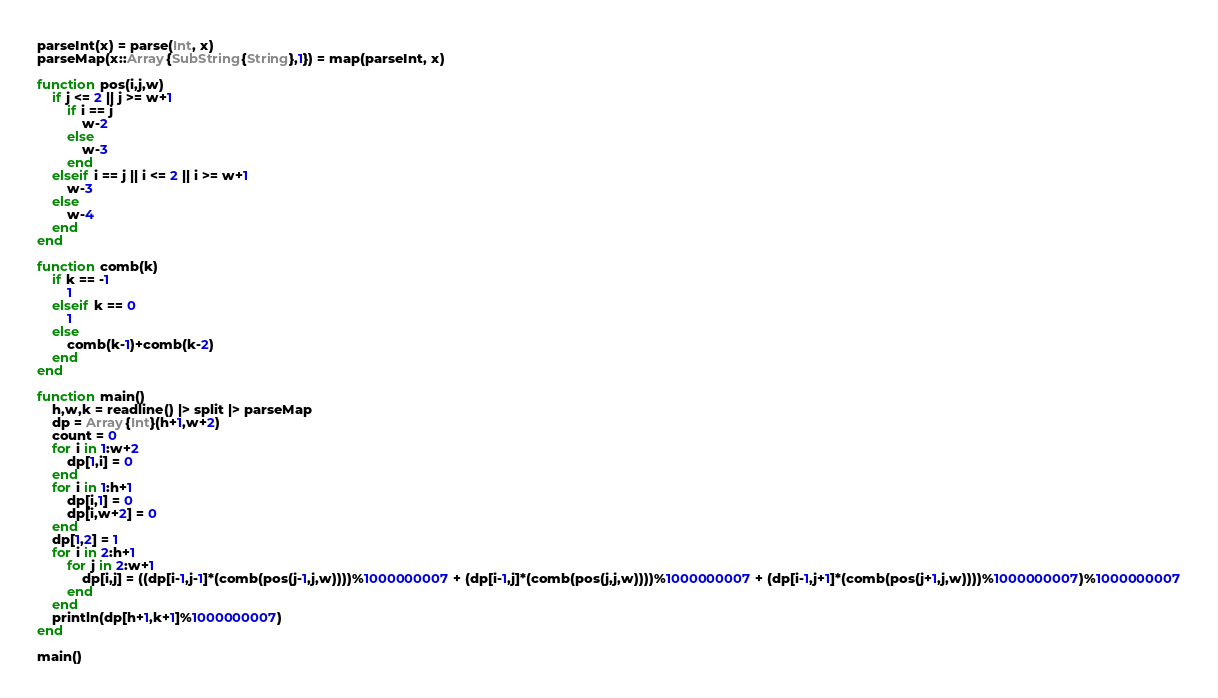<code> <loc_0><loc_0><loc_500><loc_500><_Julia_>parseInt(x) = parse(Int, x)
parseMap(x::Array{SubString{String},1}) = map(parseInt, x)

function pos(i,j,w)
	if j <= 2 || j >= w+1
    	if i == j
      		w-2
    	else
      		w-3
    	end
    elseif i == j || i <= 2 || i >= w+1
		w-3
	else
		w-4
	end
end

function comb(k)
	if k == -1
		1
	elseif k == 0
		1
	else
		comb(k-1)+comb(k-2)
	end
end

function main()
	h,w,k = readline() |> split |> parseMap
	dp = Array{Int}(h+1,w+2)
	count = 0
	for i in 1:w+2
		dp[1,i] = 0
	end
	for i in 1:h+1
		dp[i,1] = 0
		dp[i,w+2] = 0
	end
    dp[1,2] = 1
	for i in 2:h+1
		for j in 2:w+1
			dp[i,j] = ((dp[i-1,j-1]*(comb(pos(j-1,j,w))))%1000000007 + (dp[i-1,j]*(comb(pos(j,j,w))))%1000000007 + (dp[i-1,j+1]*(comb(pos(j+1,j,w))))%1000000007)%1000000007
		end
	end
	println(dp[h+1,k+1]%1000000007)
end

main()
</code> 